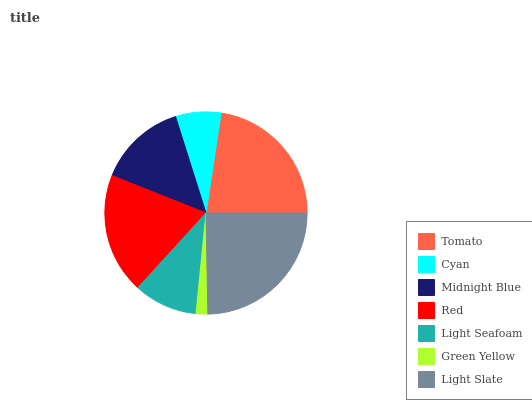Is Green Yellow the minimum?
Answer yes or no. Yes. Is Light Slate the maximum?
Answer yes or no. Yes. Is Cyan the minimum?
Answer yes or no. No. Is Cyan the maximum?
Answer yes or no. No. Is Tomato greater than Cyan?
Answer yes or no. Yes. Is Cyan less than Tomato?
Answer yes or no. Yes. Is Cyan greater than Tomato?
Answer yes or no. No. Is Tomato less than Cyan?
Answer yes or no. No. Is Midnight Blue the high median?
Answer yes or no. Yes. Is Midnight Blue the low median?
Answer yes or no. Yes. Is Light Slate the high median?
Answer yes or no. No. Is Green Yellow the low median?
Answer yes or no. No. 